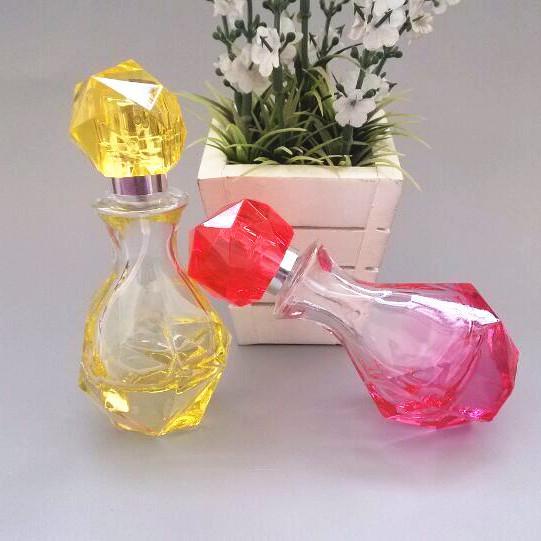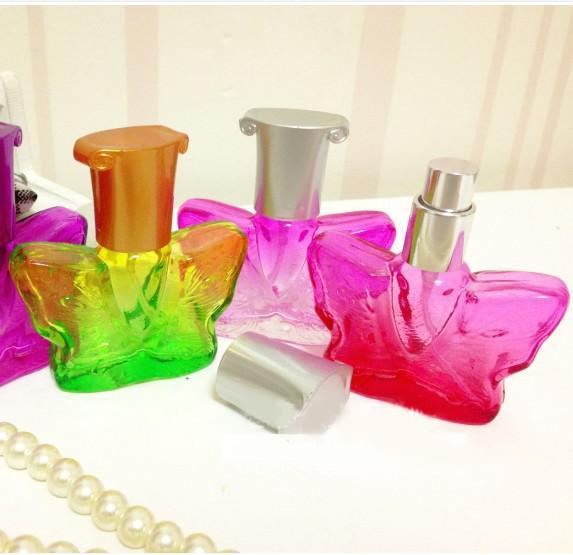The first image is the image on the left, the second image is the image on the right. Given the left and right images, does the statement "One of the images includes a string of pearls on the table." hold true? Answer yes or no. Yes. The first image is the image on the left, the second image is the image on the right. Analyze the images presented: Is the assertion "Pink flowers with green leaves flank a total of three fragrance bottles in the combined images, and at least one fragrance bottle has a clear faceted top shaped like a water drop." valid? Answer yes or no. No. 